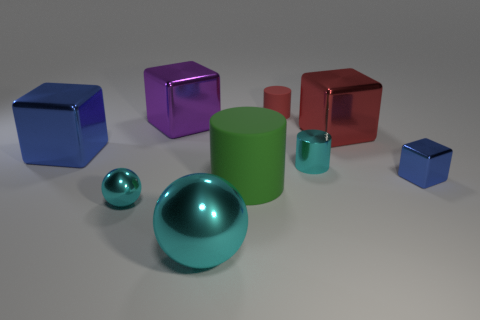Subtract all purple balls. Subtract all green cylinders. How many balls are left? 2 Subtract all cubes. How many objects are left? 5 Add 7 large green cylinders. How many large green cylinders are left? 8 Add 2 cylinders. How many cylinders exist? 5 Subtract 0 purple spheres. How many objects are left? 9 Subtract all big brown shiny cubes. Subtract all cyan shiny things. How many objects are left? 6 